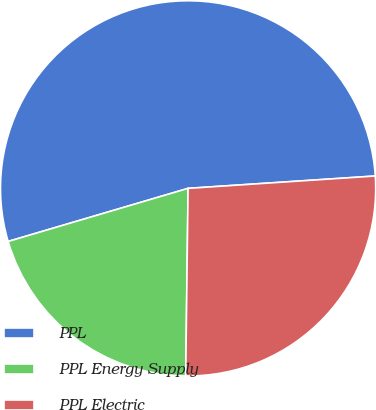Convert chart. <chart><loc_0><loc_0><loc_500><loc_500><pie_chart><fcel>PPL<fcel>PPL Energy Supply<fcel>PPL Electric<nl><fcel>53.51%<fcel>20.23%<fcel>26.25%<nl></chart> 